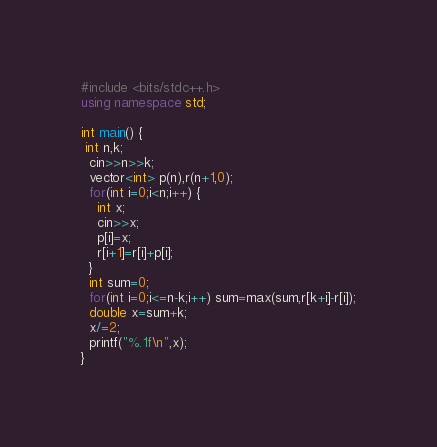<code> <loc_0><loc_0><loc_500><loc_500><_C++_>#include <bits/stdc++.h>
using namespace std;

int main() {
 int n,k;
  cin>>n>>k;
  vector<int> p(n),r(n+1,0);
  for(int i=0;i<n;i++) {
    int x;
    cin>>x;
    p[i]=x;
    r[i+1]=r[i]+p[i];
  }
  int sum=0;
  for(int i=0;i<=n-k;i++) sum=max(sum,r[k+i]-r[i]);
  double x=sum+k;
  x/=2;
  printf("%.1f\n",x);
}</code> 